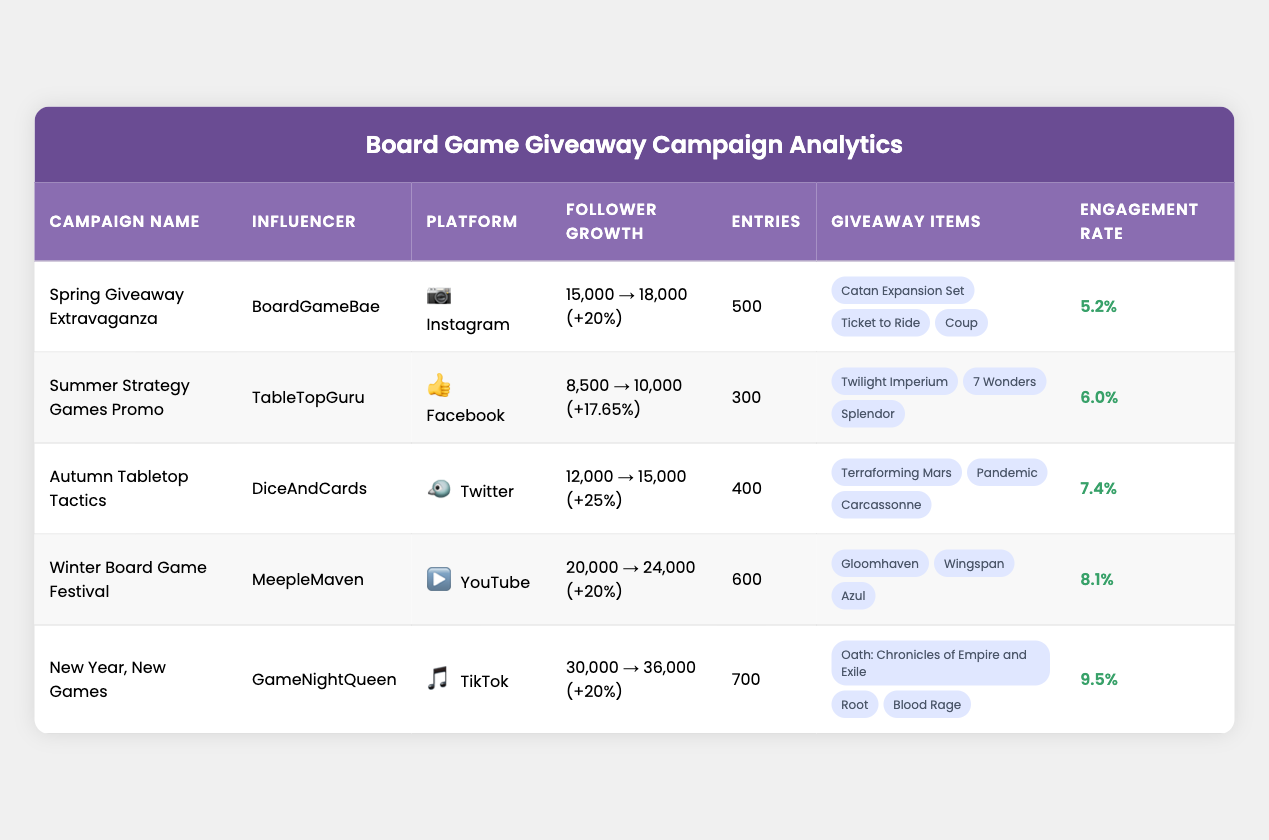What is the engagement rate of the campaign "Spring Giveaway Extravaganza"? According to the table, the engagement rate for the "Spring Giveaway Extravaganza" campaign is shown in the corresponding row under the Engagement Rate column. It reads 5.2%.
Answer: 5.2% Which campaign had the highest increase percentage in followers? By reviewing the increase percentage for each campaign, the "Autumn Tabletop Tactics" shows an increase of 25%, which is the highest compared to the other campaigns.
Answer: Autumn Tabletop Tactics How many total entries were recorded across all campaigns? The total entries can be calculated by adding up all the numbers of entries from each of the campaigns: 500 + 300 + 400 + 600 + 700 = 2500.
Answer: 2500 Did the "GameNightQueen" campaign have a higher engagement rate than the "DiceAndCards" campaign? According to the table, "GameNightQueen" has an engagement rate of 9.5%, while "DiceAndCards" has an engagement rate of 7.4%. Therefore, it is true that "GameNightQueen" had a higher engagement rate.
Answer: Yes What is the average initial follower count across all campaigns? The initial follower counts are: 15000, 8500, 12000, 20000, and 30000. Adding these gives 15000 + 8500 + 12000 + 20000 + 30000 =  82000. Dividing this total by 5 (the number of campaigns) gives an average of 82000 / 5 = 16400.
Answer: 16400 Which platform had the least number of entries in its giveaway? By comparing the number of entries listed for each platform, the "Summer Strategy Games Promo" on Facebook had 300 entries, which is the least among all the campaigns.
Answer: Facebook What is the final followers' count for the "Winter Board Game Festival"? The table explicitly indicates that the final follower count for the "Winter Board Game Festival" campaign is 24000, found in the corresponding row under the Final Followers column.
Answer: 24000 Is the average increase percentage for all campaigns greater than 20%? First, we calculate the increase percentages: 20%, 17.65%, 25%, 20%, and 20%. Adding them up gives 20 + 17.65 + 25 + 20 + 20 = 102. Dividing by 5 results in an average of 102 / 5 = 20.4%. Since 20.4% is greater than 20%, the answer is yes.
Answer: Yes 